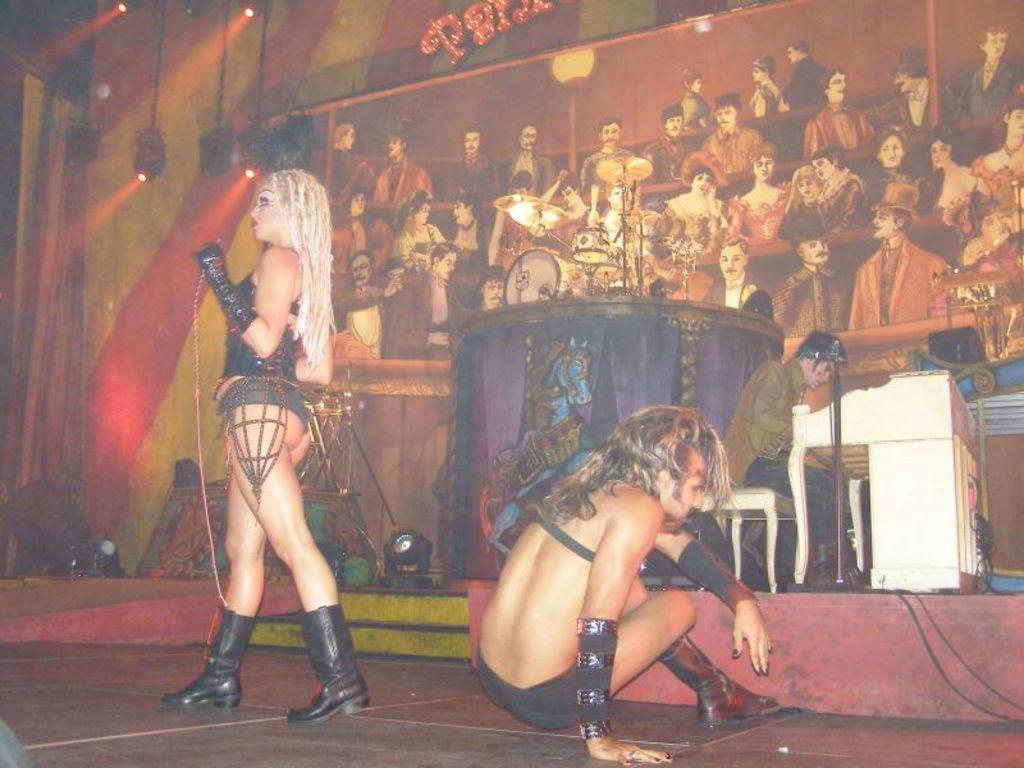In one or two sentences, can you explain what this image depicts? In this image we can see a man is sitting on the ground, beside a woman is standing, at back there a man is sitting, in front here is the table, there are musical drums, there is the light, there is a wide photo frame, at back there is a red and yellow wall. 